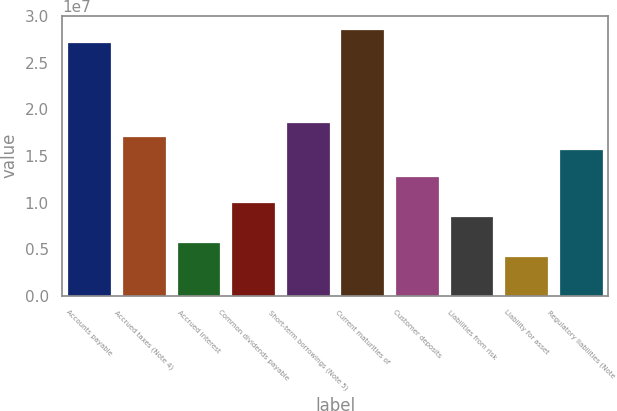Convert chart. <chart><loc_0><loc_0><loc_500><loc_500><bar_chart><fcel>Accounts payable<fcel>Accrued taxes (Note 4)<fcel>Accrued interest<fcel>Common dividends payable<fcel>Short-term borrowings (Note 5)<fcel>Current maturities of<fcel>Customer deposits<fcel>Liabilities from risk<fcel>Liability for asset<fcel>Regulatory liabilities (Note<nl><fcel>2.71926e+07<fcel>1.71756e+07<fcel>5.72745e+06<fcel>1.00205e+07<fcel>1.86066e+07<fcel>2.86237e+07<fcel>1.28825e+07<fcel>8.58948e+06<fcel>4.29644e+06<fcel>1.57445e+07<nl></chart> 